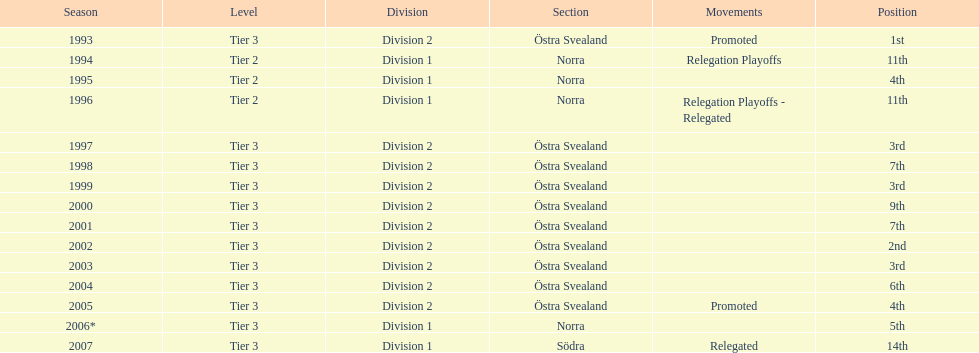In total, how many times were they promoted? 2. 